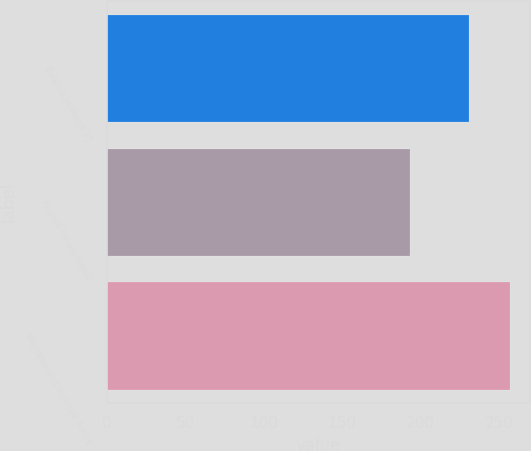<chart> <loc_0><loc_0><loc_500><loc_500><bar_chart><fcel>Balance at March 31<fcel>Accrual for warranties<fcel>Warranty cost incurred during<nl><fcel>231<fcel>193<fcel>257<nl></chart> 